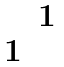Convert formula to latex. <formula><loc_0><loc_0><loc_500><loc_500>\begin{matrix} & 1 \\ 1 & \end{matrix}</formula> 